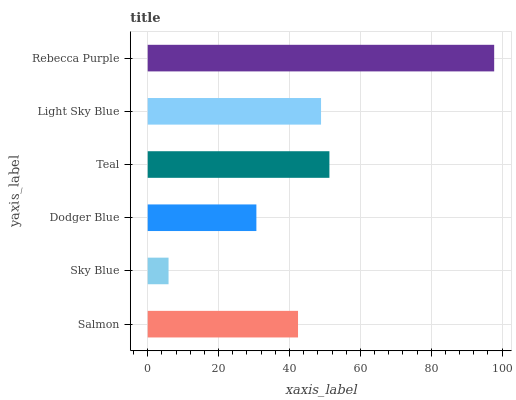Is Sky Blue the minimum?
Answer yes or no. Yes. Is Rebecca Purple the maximum?
Answer yes or no. Yes. Is Dodger Blue the minimum?
Answer yes or no. No. Is Dodger Blue the maximum?
Answer yes or no. No. Is Dodger Blue greater than Sky Blue?
Answer yes or no. Yes. Is Sky Blue less than Dodger Blue?
Answer yes or no. Yes. Is Sky Blue greater than Dodger Blue?
Answer yes or no. No. Is Dodger Blue less than Sky Blue?
Answer yes or no. No. Is Light Sky Blue the high median?
Answer yes or no. Yes. Is Salmon the low median?
Answer yes or no. Yes. Is Teal the high median?
Answer yes or no. No. Is Teal the low median?
Answer yes or no. No. 